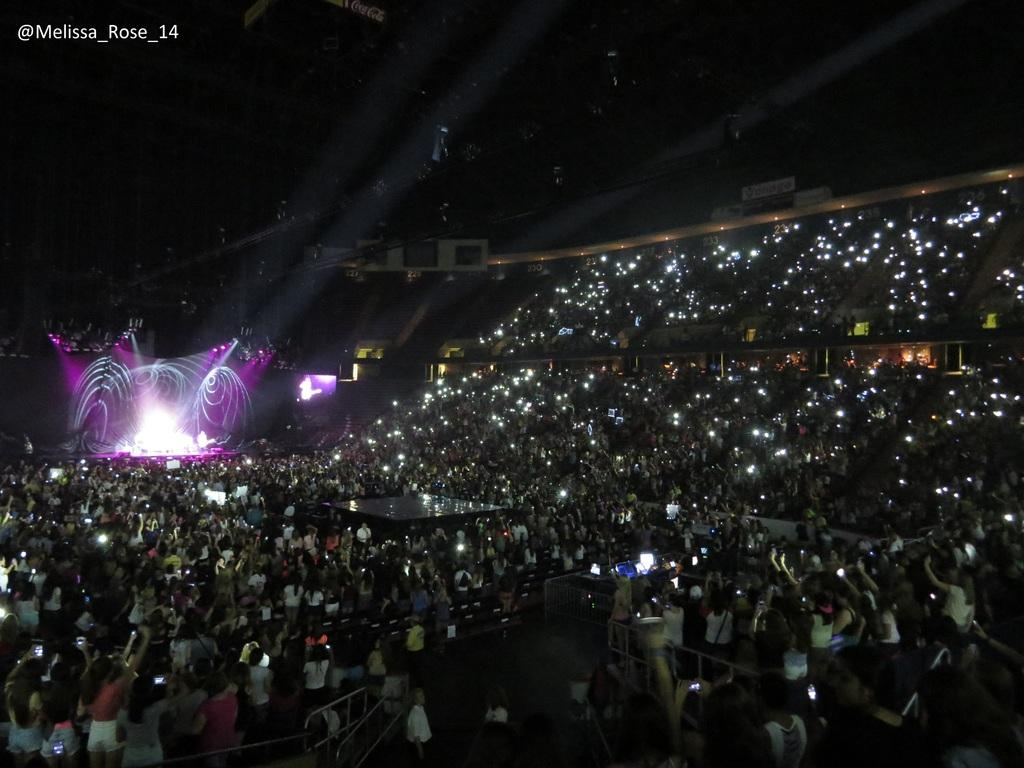How many people are in the image? There is a group of people in the image, but the exact number cannot be determined from the provided facts. What can be seen illuminating the scene in the image? There are lights visible in the image. What is displayed on the screen in the background? There appears to be a screen displaying something in the background, but the specific content cannot be determined from the provided facts. What is written or displayed at the top right corner of the image? There is text present at the top right corner of the image, but the specific content cannot be determined from the provided facts. What type of powder is being used by the people in the image? There is no indication of any powder being used by the people in the image. 